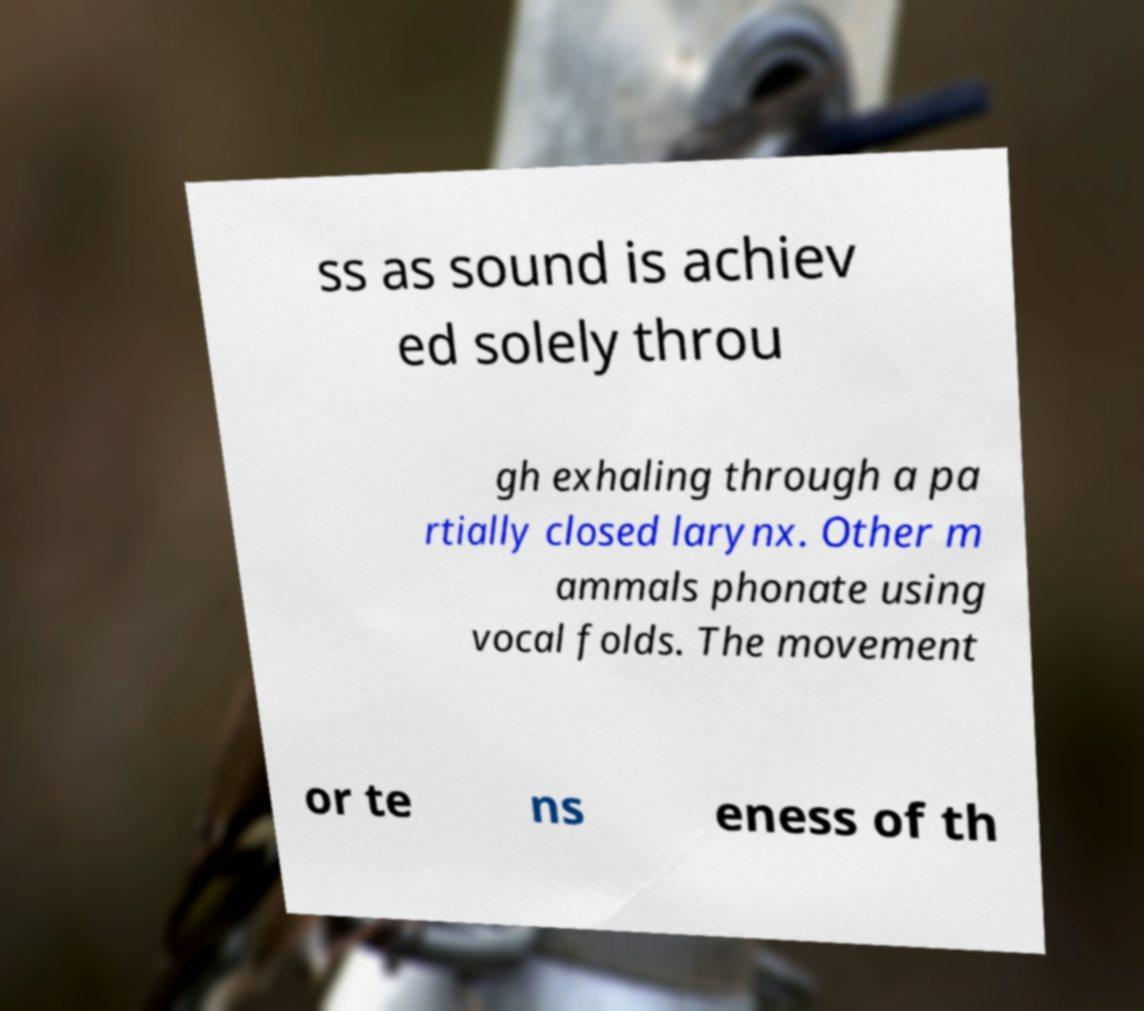Could you assist in decoding the text presented in this image and type it out clearly? ss as sound is achiev ed solely throu gh exhaling through a pa rtially closed larynx. Other m ammals phonate using vocal folds. The movement or te ns eness of th 